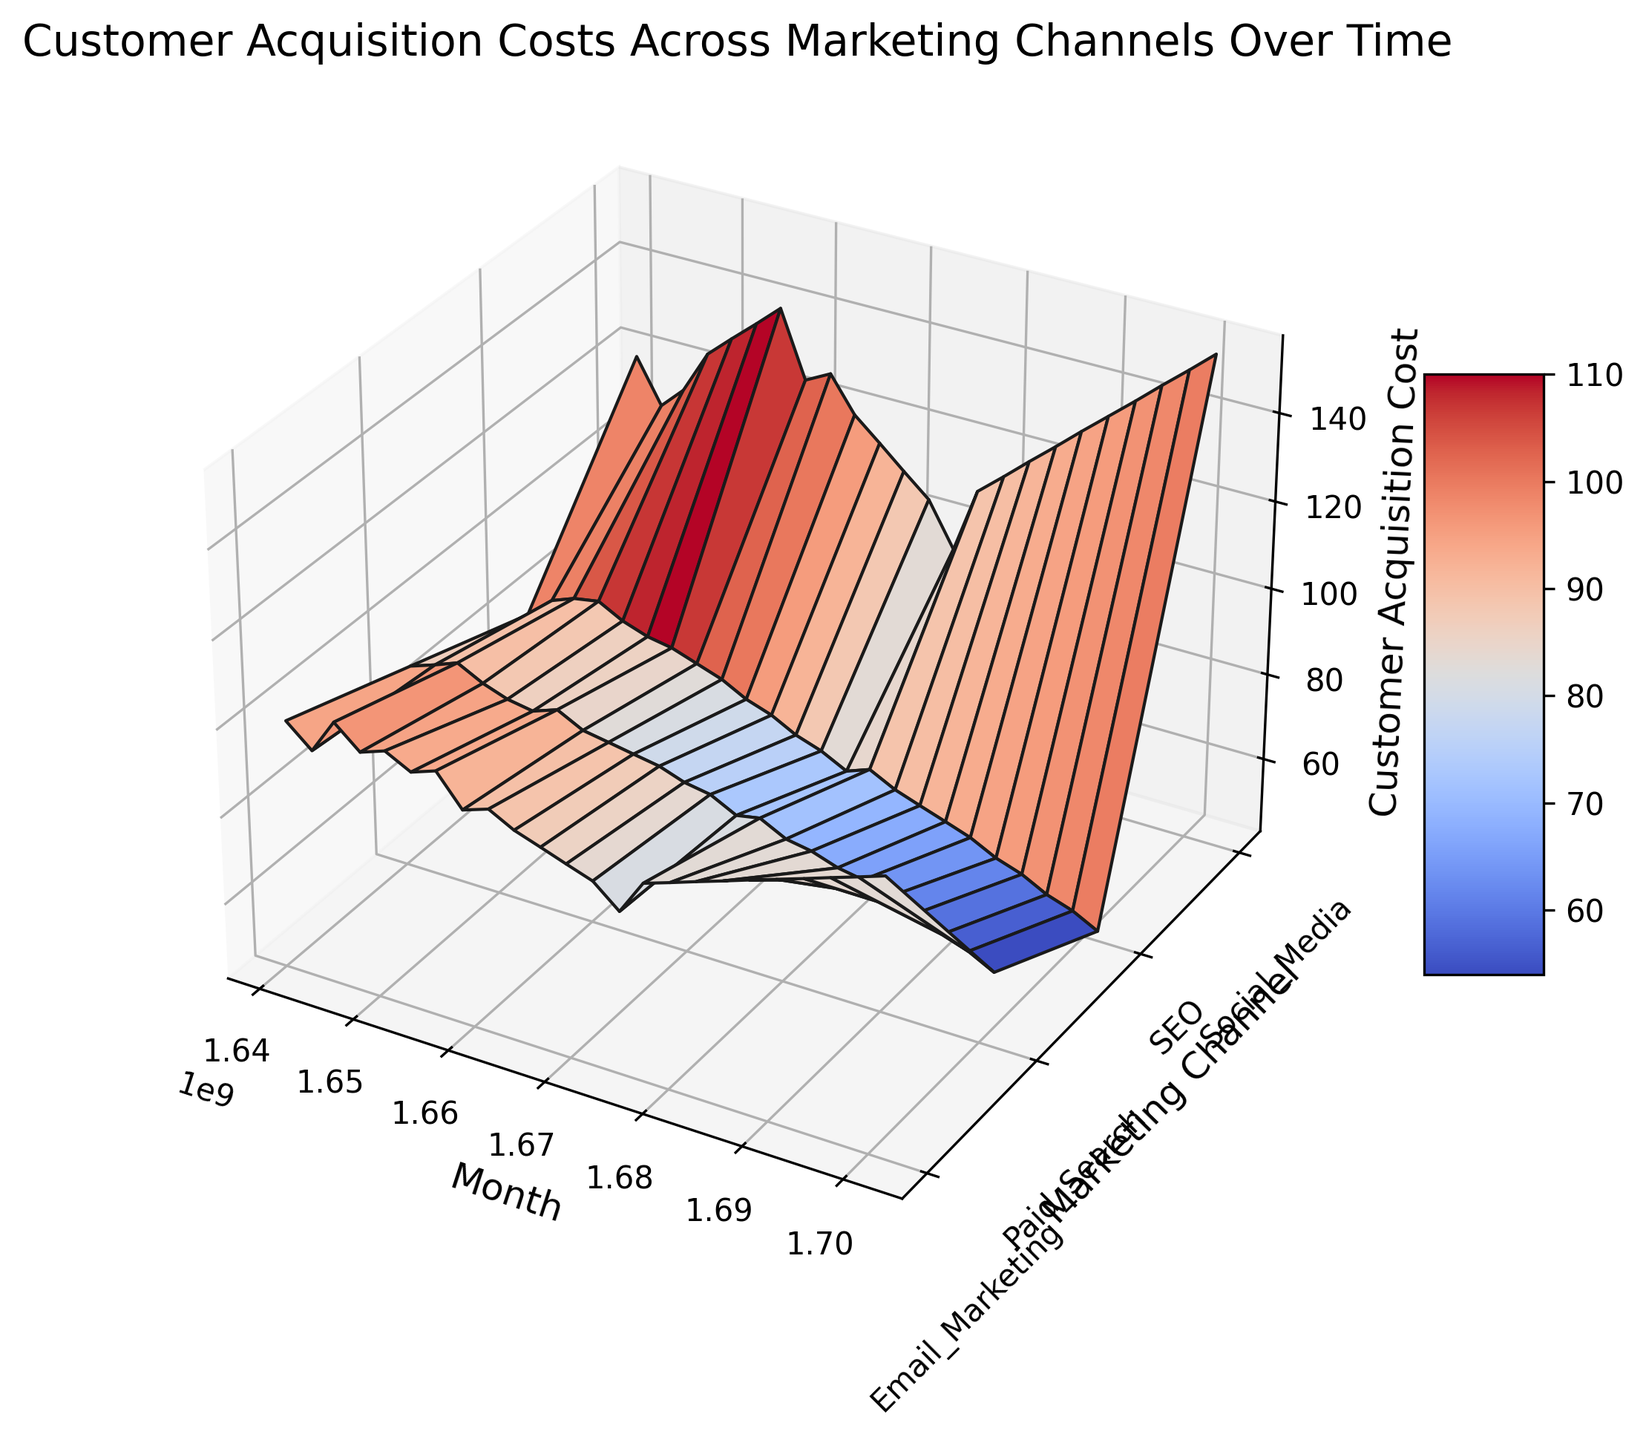Which marketing channel had the highest customer acquisition cost in January 2023? Examine the 3D surface for January 2023 and look for the highest peak among the marketing channels. The highest point is found by identifying the tallest surface value.
Answer: Social Media How did the customer acquisition cost for SEO change over the entire time period? Analyze the surface that represents SEO across different months. Observe how the surface height decreases as you move from left (earlier months) to right (later months). This indicates a consistent decline in the cost.
Answer: Consistently decreased In which month did Paid Search have the lowest customer acquisition cost? Look along the Paid Search surface and identify the lowest point on the Z-axis. The month directly below this point on the X-axis is the month with the lowest cost.
Answer: December 2023 Compare the customer acquisition costs for Social Media and Email Marketing in July 2023. Which was higher? Find the data points for Social Media and Email Marketing in July 2023 on their respective surfaces. Compare the heights of these points to determine which is higher.
Answer: Social Media What is the approximate customer acquisition cost of Paid Search in February 2023? Locate the February 2023 position on the X-axis. Follow the line up to the Paid Search surface and read the height (Z-axis) value.
Answer: 78 Between which consecutive months did Social Media experience the largest increase in customer acquisition cost? Examine the surface representing Social Media and identify the segments with the steepest upward slope. Calculate the differences between consecutive months to find the largest increase.
Answer: July 2023 and August 2023 What is the visual trend observed for the customer acquisition cost of Email Marketing over the year 2023? Observe the surface representing Email Marketing from January 2023 to December 2023. Note whether the surface height increases, decreases, or remains relatively stable.
Answer: Increasing Which marketing channel had the most consistent customer acquisition costs over time? Look at the surfaces for each marketing channel and assess their smoothness and flatness over the time period. The most consistent one will have the least variation in height.
Answer: SEO In which month did the SEO channel start to show a notable decrease in customer acquisition cost? Locate the peak and then observe where a notable downward slope starts along the SEO surface.
Answer: August 2022 